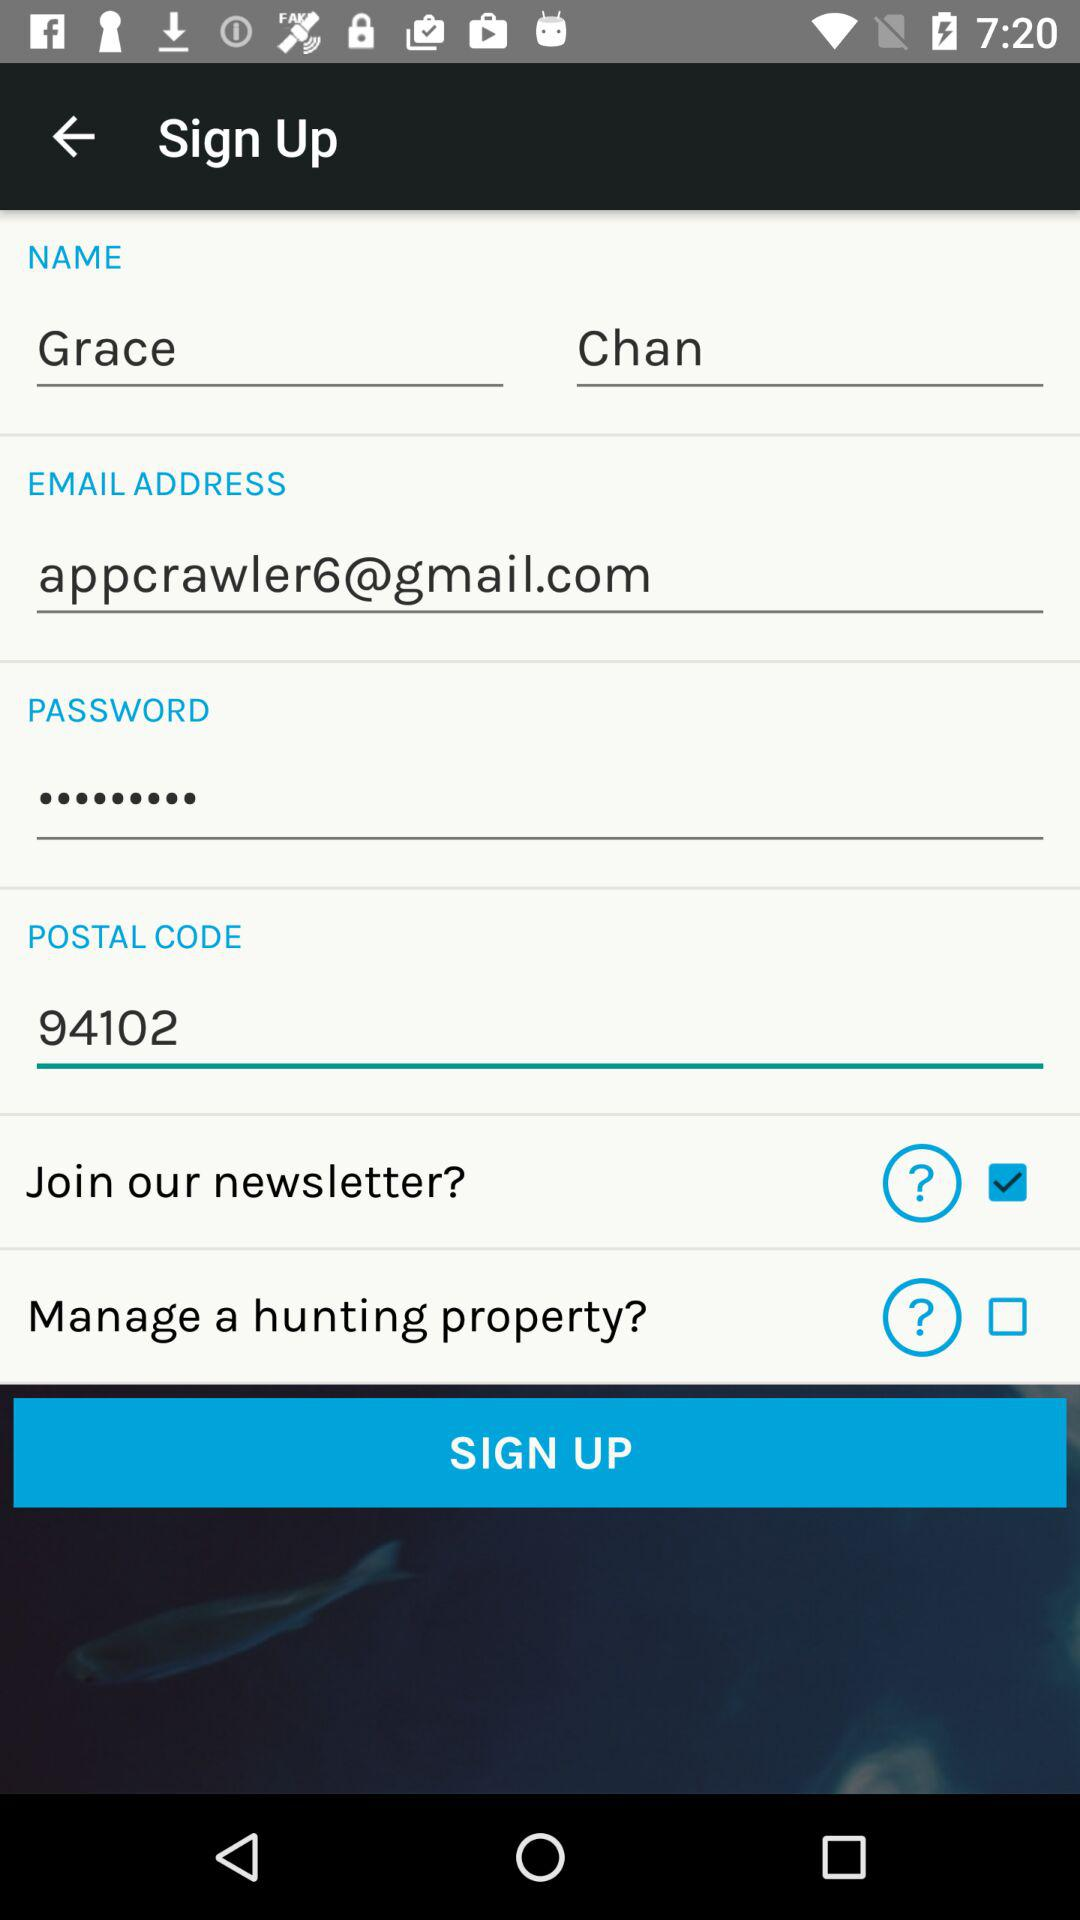What is the email address of the user? The email address of the user is appcrawler6@gmail.com. 